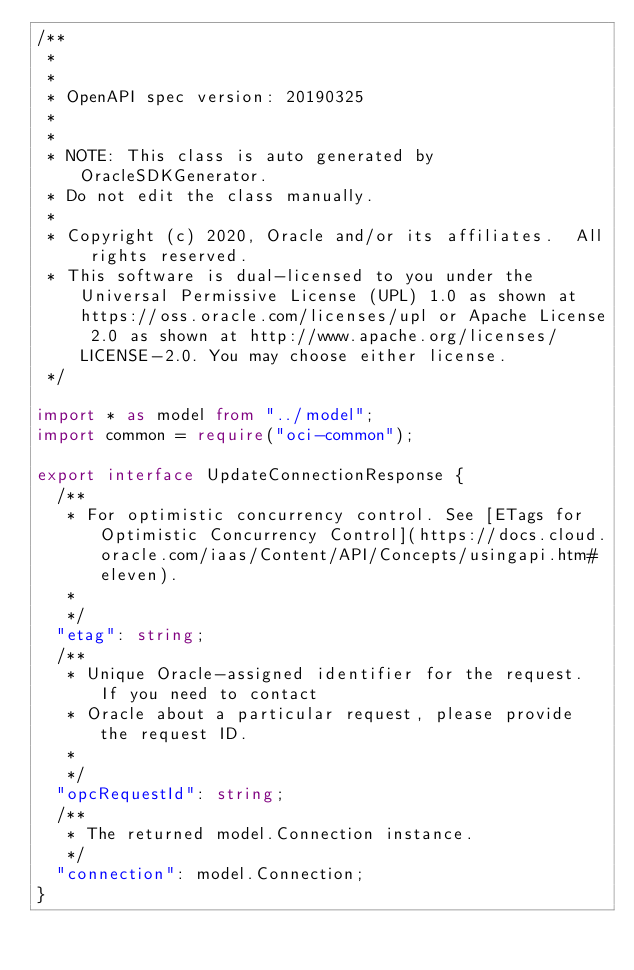Convert code to text. <code><loc_0><loc_0><loc_500><loc_500><_TypeScript_>/**
 *
 *
 * OpenAPI spec version: 20190325
 *
 *
 * NOTE: This class is auto generated by OracleSDKGenerator.
 * Do not edit the class manually.
 *
 * Copyright (c) 2020, Oracle and/or its affiliates.  All rights reserved.
 * This software is dual-licensed to you under the Universal Permissive License (UPL) 1.0 as shown at https://oss.oracle.com/licenses/upl or Apache License 2.0 as shown at http://www.apache.org/licenses/LICENSE-2.0. You may choose either license.
 */

import * as model from "../model";
import common = require("oci-common");

export interface UpdateConnectionResponse {
  /**
   * For optimistic concurrency control. See [ETags for Optimistic Concurrency Control](https://docs.cloud.oracle.com/iaas/Content/API/Concepts/usingapi.htm#eleven).
   *
   */
  "etag": string;
  /**
   * Unique Oracle-assigned identifier for the request. If you need to contact
   * Oracle about a particular request, please provide the request ID.
   *
   */
  "opcRequestId": string;
  /**
   * The returned model.Connection instance.
   */
  "connection": model.Connection;
}
</code> 